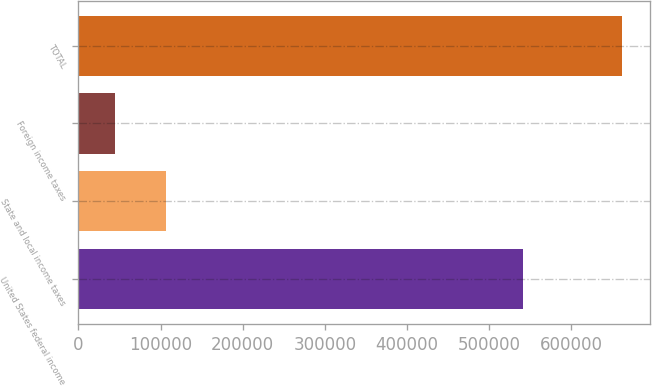Convert chart to OTSL. <chart><loc_0><loc_0><loc_500><loc_500><bar_chart><fcel>United States federal income<fcel>State and local income taxes<fcel>Foreign income taxes<fcel>TOTAL<nl><fcel>540861<fcel>106284<fcel>44492<fcel>662417<nl></chart> 